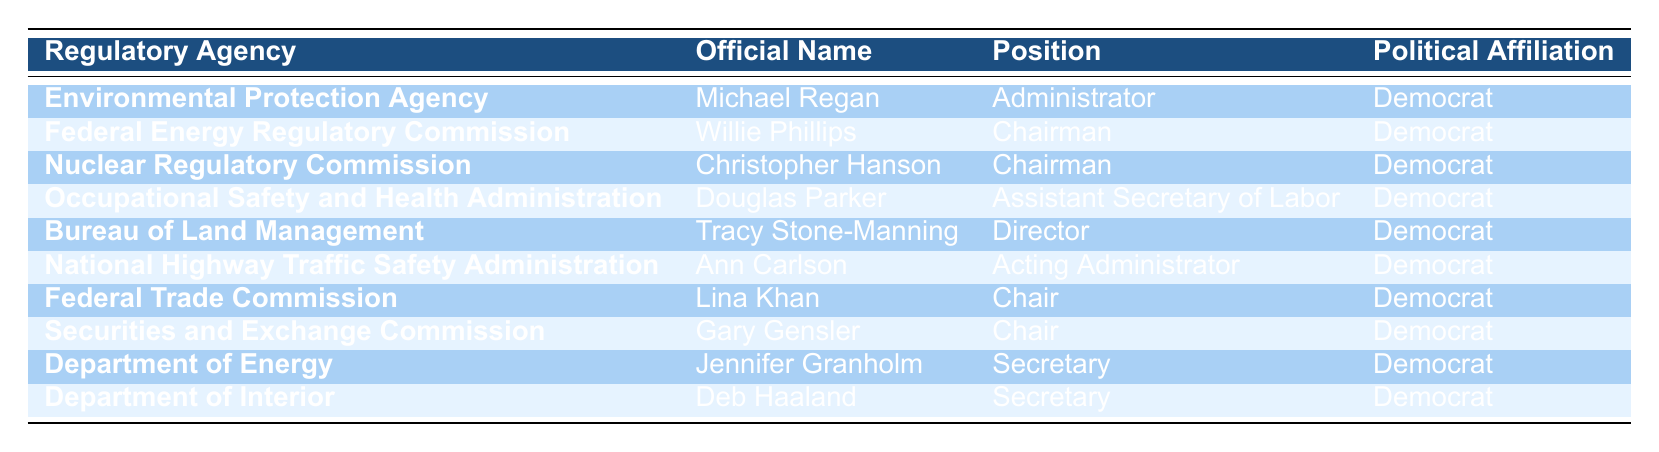What is the political affiliation of the Administrator of the Environmental Protection Agency? The Administrator of the Environmental Protection Agency is Michael Regan, and his political affiliation is listed as Democrat.
Answer: Democrat How many officials in the table have a political affiliation of Democrat? All of the officials listed in the table are affiliated with the Democratic Party, totaling 10 officials.
Answer: 10 Is there any official from the Nuclear Regulatory Commission affiliated with the Republican Party? Upon examining the table, there is no official listed from the Nuclear Regulatory Commission affiliated with the Republican Party; all are affiliates of the Democratic Party.
Answer: No Name the positions held by officials affiliated with the Department of Energy and Department of Interior. The Secretary of the Department of Energy is Jennifer Granholm, and the Secretary of the Department of Interior is Deb Haaland; both positions are held by officials affiliated with the Democratic Party.
Answer: Secretary (Department of Energy), Secretary (Department of Interior) Which regulatory agency has its official with the title of Assistant Secretary of Labor? The Occupational Safety and Health Administration has Douglas Parker serving as the Assistant Secretary of Labor.
Answer: Occupational Safety and Health Administration Are all regulatory agencies listed in the table affiliated with the same political party? Yes, examining each entry in the table confirms that all listed regulatory agencies have officials affiliated with the Democratic Party.
Answer: Yes What is the total number of chairpersons in the table and what is their political affiliation? There are three chairpersons listed in the table: Willie Phillips (Federal Energy Regulatory Commission), Christopher Hanson (Nuclear Regulatory Commission), and Lina Khan (Federal Trade Commission), all of whom are affiliated with the Democratic Party.
Answer: 3 Chairpersons; Democrat If we consider the total political positions listed, what percentage is the role of Chair compared to the total positions? There are 3 Chairpersons among 10 total officials. The percentage is calculated as (3/10) * 100, which equals 30%.
Answer: 30% Which official has the role of Acting Administrator and what is their political affiliation? The official with the role of Acting Administrator is Ann Carlson from the National Highway Traffic Safety Administration, and her political affiliation is Democrat.
Answer: Ann Carlson, Democrat 